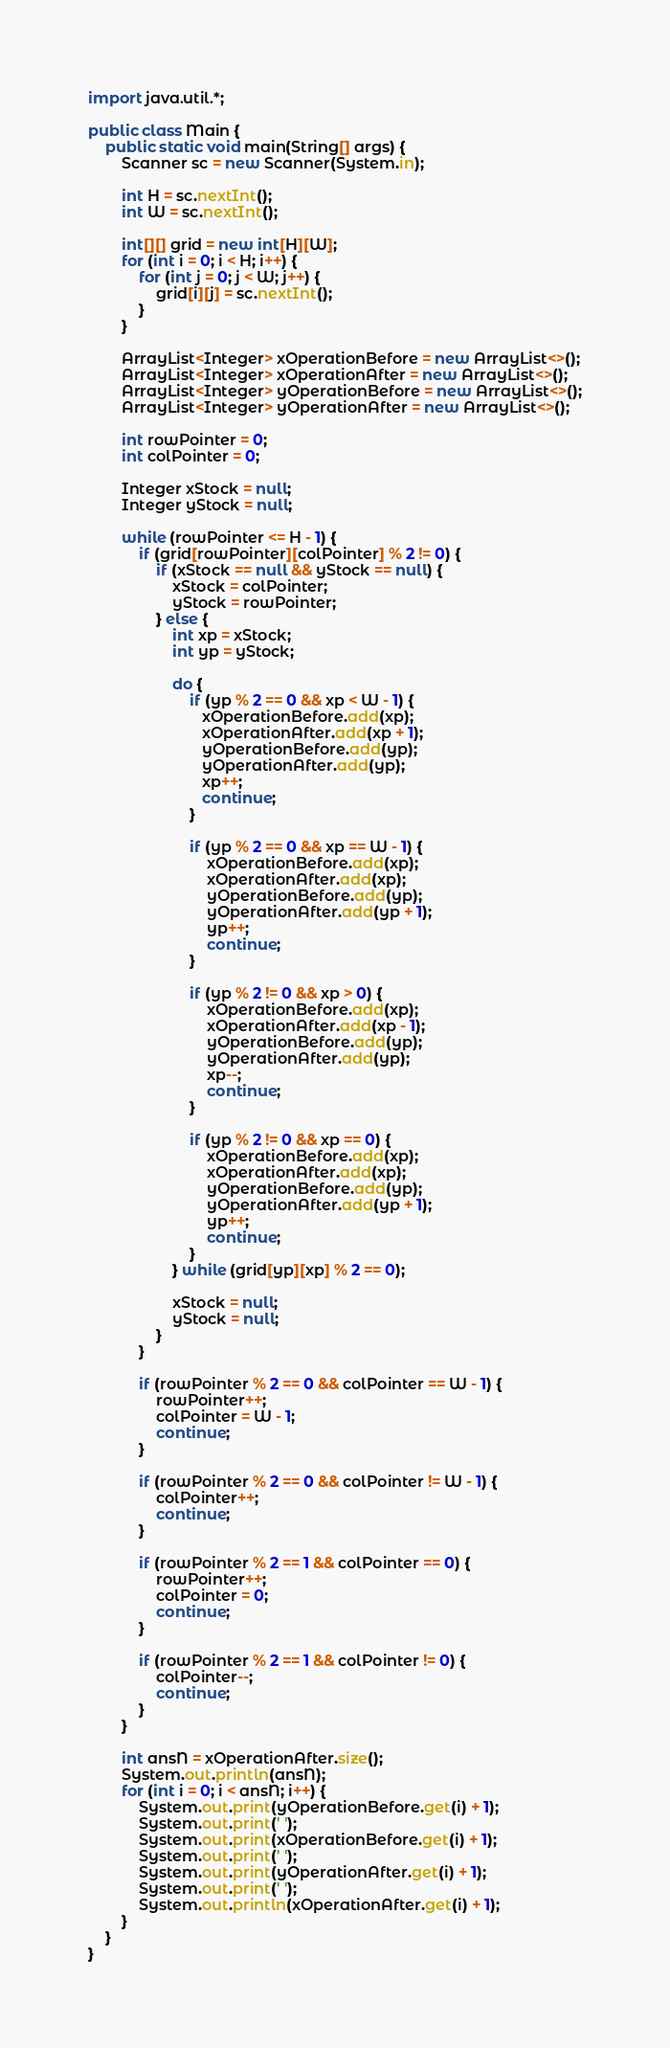Convert code to text. <code><loc_0><loc_0><loc_500><loc_500><_Java_>import java.util.*;

public class Main {
    public static void main(String[] args) {
        Scanner sc = new Scanner(System.in);

        int H = sc.nextInt();
        int W = sc.nextInt();

        int[][] grid = new int[H][W];
        for (int i = 0; i < H; i++) {
            for (int j = 0; j < W; j++) {
                grid[i][j] = sc.nextInt();
            }
        }

        ArrayList<Integer> xOperationBefore = new ArrayList<>();
        ArrayList<Integer> xOperationAfter = new ArrayList<>();
        ArrayList<Integer> yOperationBefore = new ArrayList<>();
        ArrayList<Integer> yOperationAfter = new ArrayList<>();

        int rowPointer = 0;
        int colPointer = 0;

        Integer xStock = null;
        Integer yStock = null;

        while (rowPointer <= H - 1) {
            if (grid[rowPointer][colPointer] % 2 != 0) {
                if (xStock == null && yStock == null) {
                    xStock = colPointer;
                    yStock = rowPointer;
                } else {
                    int xp = xStock;
                    int yp = yStock;

                    do {
                        if (yp % 2 == 0 && xp < W - 1) {
                           xOperationBefore.add(xp);
                           xOperationAfter.add(xp + 1);
                           yOperationBefore.add(yp);
                           yOperationAfter.add(yp);
                           xp++;
                           continue;
                        }

                        if (yp % 2 == 0 && xp == W - 1) {
                            xOperationBefore.add(xp);
                            xOperationAfter.add(xp);
                            yOperationBefore.add(yp);
                            yOperationAfter.add(yp + 1);
                            yp++;
                            continue;
                        }

                        if (yp % 2 != 0 && xp > 0) {
                            xOperationBefore.add(xp);
                            xOperationAfter.add(xp - 1);
                            yOperationBefore.add(yp);
                            yOperationAfter.add(yp);
                            xp--;
                            continue;
                        }

                        if (yp % 2 != 0 && xp == 0) {
                            xOperationBefore.add(xp);
                            xOperationAfter.add(xp);
                            yOperationBefore.add(yp);
                            yOperationAfter.add(yp + 1);
                            yp++;
                            continue;
                        }
                    } while (grid[yp][xp] % 2 == 0);

                    xStock = null;
                    yStock = null;
                }
            }

            if (rowPointer % 2 == 0 && colPointer == W - 1) {
                rowPointer++;
                colPointer = W - 1;
                continue;
            }

            if (rowPointer % 2 == 0 && colPointer != W - 1) {
                colPointer++;
                continue;
            }

            if (rowPointer % 2 == 1 && colPointer == 0) {
                rowPointer++;
                colPointer = 0;
                continue;
            }

            if (rowPointer % 2 == 1 && colPointer != 0) {
                colPointer--;
                continue;
            }
        }

        int ansN = xOperationAfter.size();
        System.out.println(ansN);
        for (int i = 0; i < ansN; i++) {
            System.out.print(yOperationBefore.get(i) + 1);
            System.out.print(' ');
            System.out.print(xOperationBefore.get(i) + 1);
            System.out.print(' ');
            System.out.print(yOperationAfter.get(i) + 1);
            System.out.print(' ');
            System.out.println(xOperationAfter.get(i) + 1);
        }
    }
}</code> 